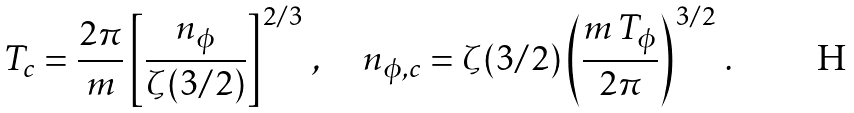<formula> <loc_0><loc_0><loc_500><loc_500>T _ { c } = \frac { 2 \pi } { m } \left [ \frac { n _ { \phi } } { \zeta ( 3 / 2 ) } \right ] ^ { 2 / 3 } \, , \quad n _ { \phi , c } = \zeta ( 3 / 2 ) \left ( \frac { m \, T _ { \phi } } { 2 \pi } \right ) ^ { 3 / 2 } \, .</formula> 